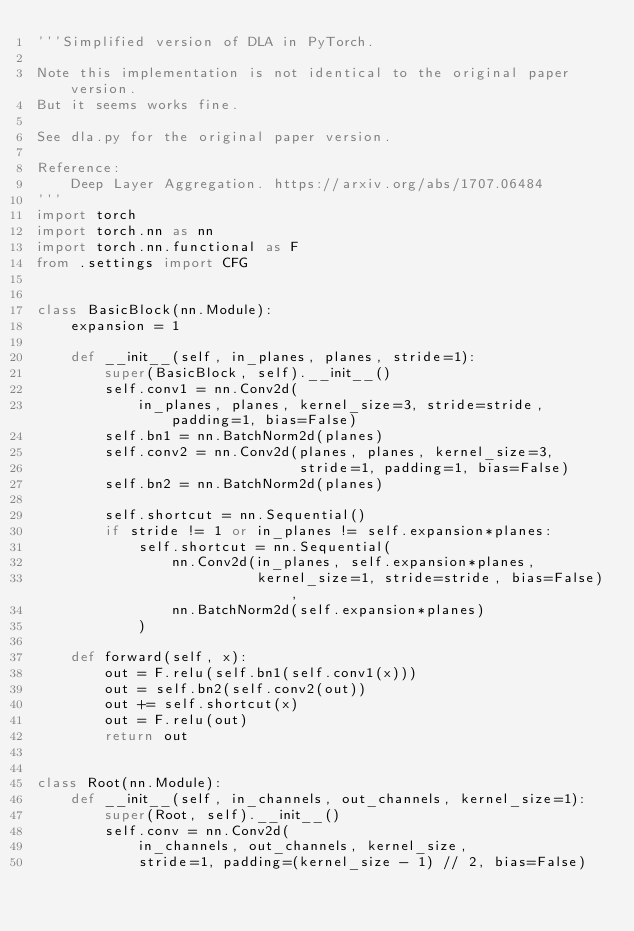Convert code to text. <code><loc_0><loc_0><loc_500><loc_500><_Python_>'''Simplified version of DLA in PyTorch.

Note this implementation is not identical to the original paper version.
But it seems works fine.

See dla.py for the original paper version.

Reference:
    Deep Layer Aggregation. https://arxiv.org/abs/1707.06484
'''
import torch
import torch.nn as nn
import torch.nn.functional as F
from .settings import CFG


class BasicBlock(nn.Module):
    expansion = 1

    def __init__(self, in_planes, planes, stride=1):
        super(BasicBlock, self).__init__()
        self.conv1 = nn.Conv2d(
            in_planes, planes, kernel_size=3, stride=stride, padding=1, bias=False)
        self.bn1 = nn.BatchNorm2d(planes)
        self.conv2 = nn.Conv2d(planes, planes, kernel_size=3,
                               stride=1, padding=1, bias=False)
        self.bn2 = nn.BatchNorm2d(planes)

        self.shortcut = nn.Sequential()
        if stride != 1 or in_planes != self.expansion*planes:
            self.shortcut = nn.Sequential(
                nn.Conv2d(in_planes, self.expansion*planes,
                          kernel_size=1, stride=stride, bias=False),
                nn.BatchNorm2d(self.expansion*planes)
            )

    def forward(self, x):
        out = F.relu(self.bn1(self.conv1(x)))
        out = self.bn2(self.conv2(out))
        out += self.shortcut(x)
        out = F.relu(out)
        return out


class Root(nn.Module):
    def __init__(self, in_channels, out_channels, kernel_size=1):
        super(Root, self).__init__()
        self.conv = nn.Conv2d(
            in_channels, out_channels, kernel_size,
            stride=1, padding=(kernel_size - 1) // 2, bias=False)</code> 